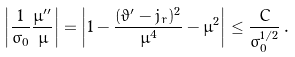<formula> <loc_0><loc_0><loc_500><loc_500>\left | \frac { 1 } { \sigma _ { 0 } } \frac { \mu ^ { \prime \prime } } { \mu } \right | = \left | 1 - \frac { ( \vartheta ^ { \prime } - j _ { r } ) ^ { 2 } } { \mu ^ { 4 } } - \mu ^ { 2 } \right | \leq \frac { C } { \sigma _ { 0 } ^ { 1 / 2 } } \, .</formula> 